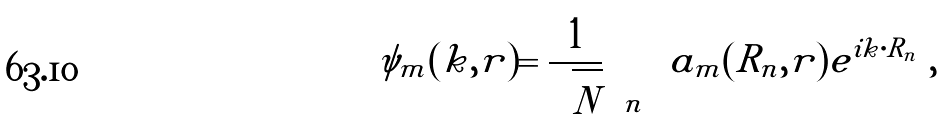<formula> <loc_0><loc_0><loc_500><loc_500>\psi _ { m } ( k , r ) = { \frac { 1 } { \sqrt { N } } } \sum _ { n } { a _ { m } ( R _ { n } , r ) } e ^ { i k \cdot R _ { n } } \ ,</formula> 